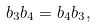<formula> <loc_0><loc_0><loc_500><loc_500>b _ { 3 } b _ { 4 } = b _ { 4 } b _ { 3 } ,</formula> 